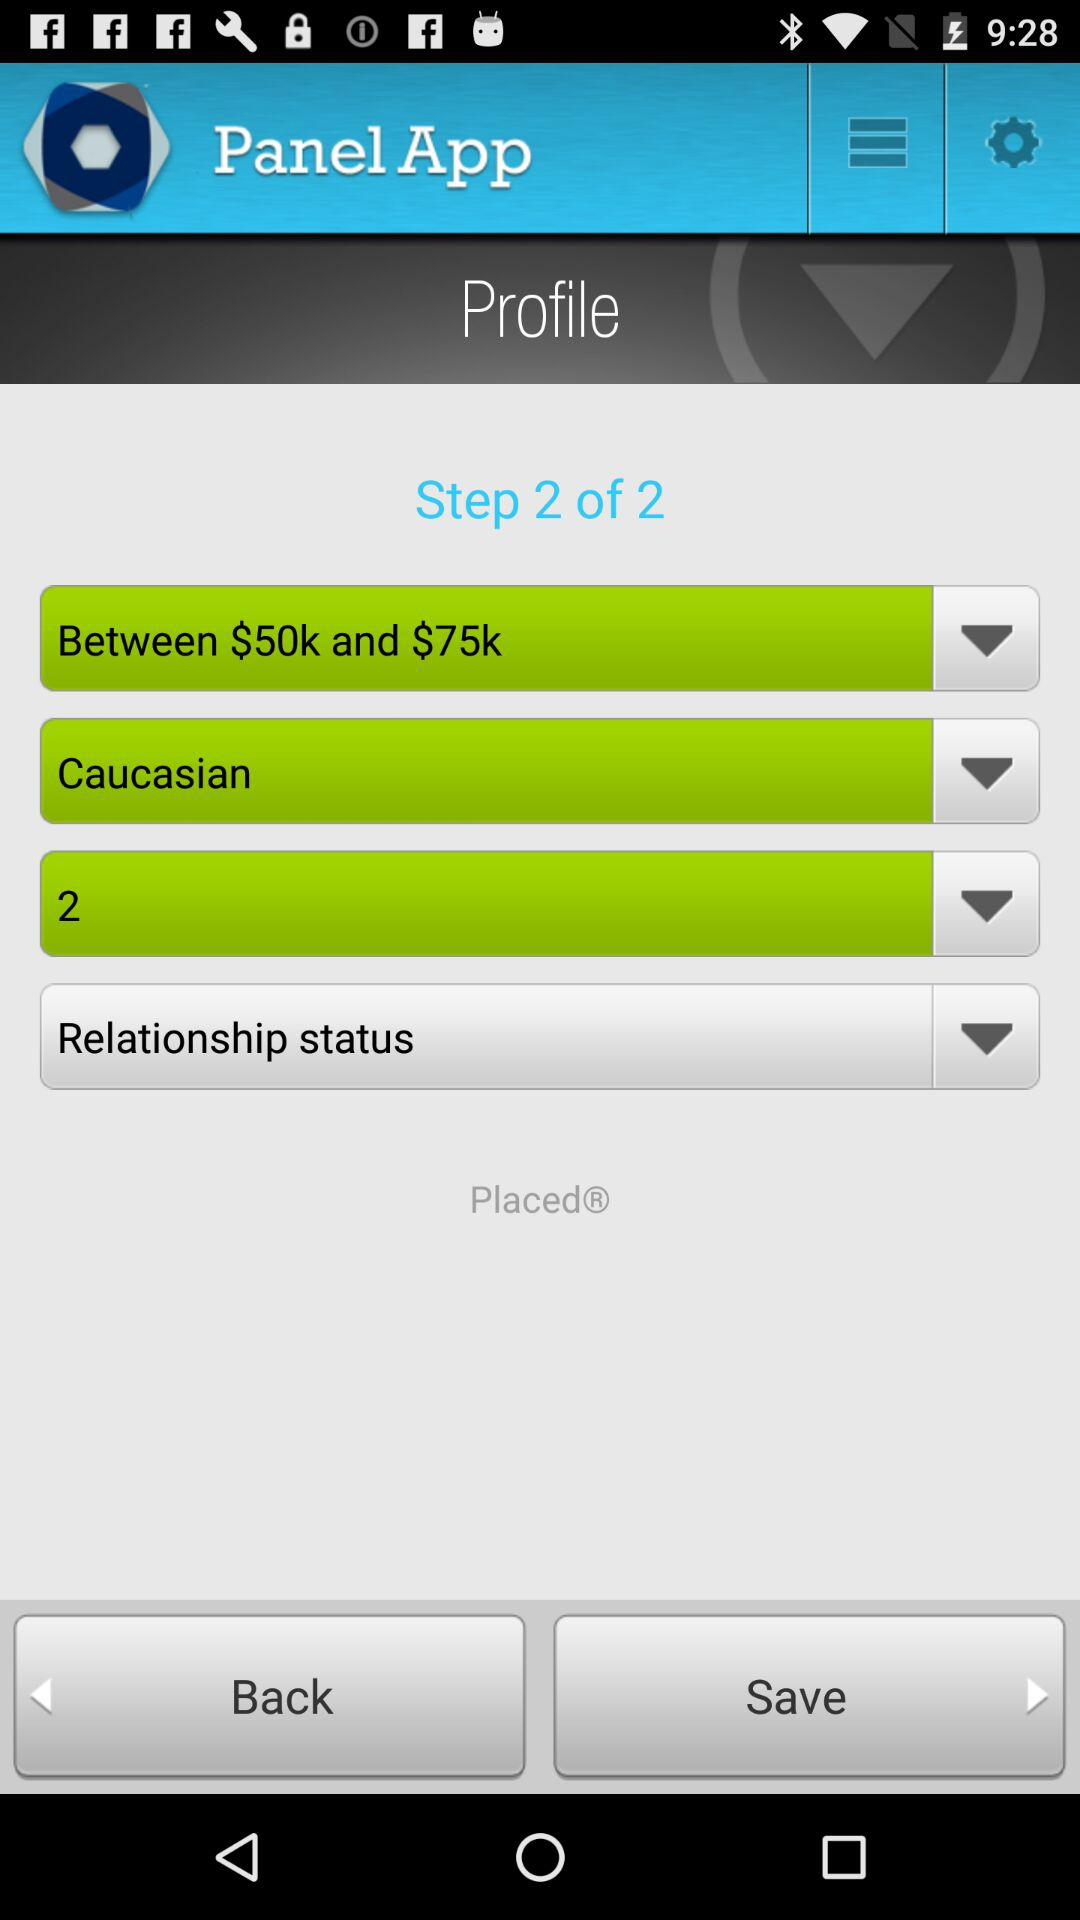What is the given price range? The given price range is between $50k and $75k. 